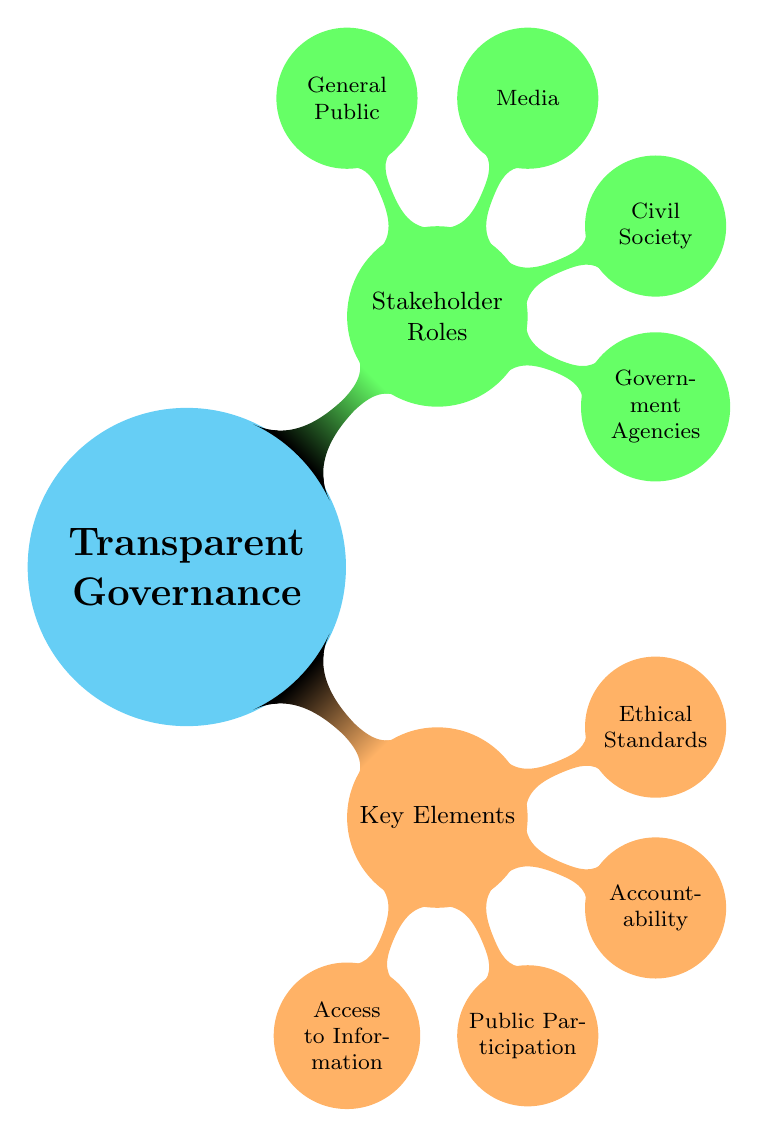What is the main topic of the mind map? The central concept of the mind map is "Transparent Governance," which is represented at the core of the diagram.
Answer: Transparent Governance How many key elements are listed under "Key Elements"? There are four key elements mentioned in the diagram: Access to Information, Public Participation, Accountability, and Ethical Standards. Counting these components gives us a total of four.
Answer: 4 What is one of the roles of the Civil Society? The diagram indicates that one of the roles of Civil Society is played by Non-Governmental Organizations. This information can be found under the "Civil Society" node.
Answer: Non-Governmental Organizations Which stakeholder is associated with "Public Broadcasters"? "Public Broadcasters" is a role listed under the "Media" stakeholder category in the mind map. This shows that Media plays an important role in the context of transparent governance.
Answer: Media What are the two examples of "Accountability"? The examples listed under "Accountability" are "Independent Audits" and "Whistleblower Protections." The diagram clearly states these two items as part of the accountability mechanism.
Answer: Independent Audits, Whistleblower Protections Which node has the most child nodes? The node "Key Elements" has four child nodes related to essential aspects of transparent governance, which is the highest number among the different categories shown in the diagram.
Answer: Key Elements What is the relationship between "General Public" and "Advocacy Groups"? "Advocacy Groups" is one of the two roles identified under the "General Public" stakeholder node, indicating that advocacy is an important function of the general public in promoting transparency.
Answer: General Public How many stakeholder types are represented in this mind map? The mind map includes four distinct stakeholder types, which are Government Agencies, Civil Society, Media, and General Public. Counting these reveals that there are four stakeholder types overall.
Answer: 4 What is one example under "Access to Information"? One example under "Access to Information" is "Open Data Portals," which illustrates how information can be made accessible to the public. This is part of the broader category focused on transparency.
Answer: Open Data Portals 